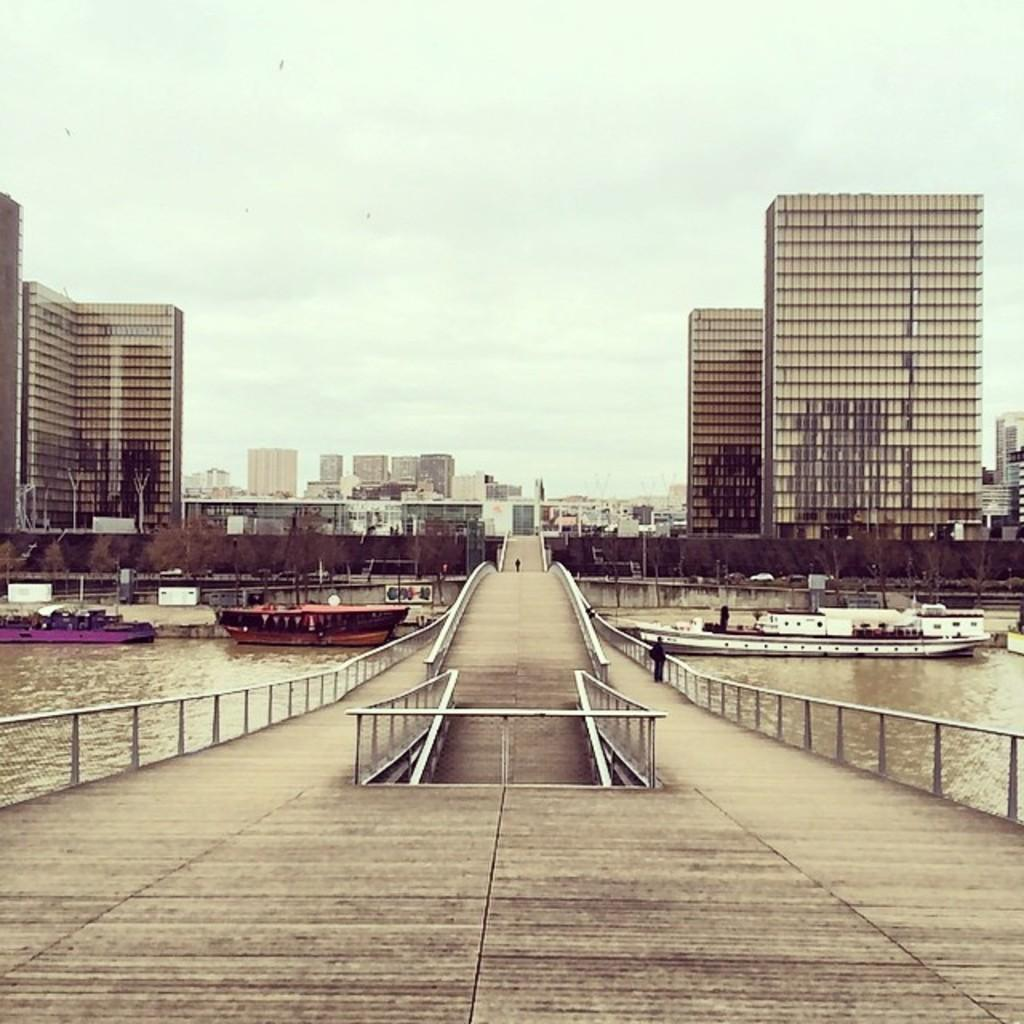What is on the water in the image? There are boats on the water in the image. What structure can be seen crossing over the water? There is a bridge with a fence in the image. What can be seen in the distance behind the bridge? There are buildings visible in the background of the image. What is visible above the bridge and buildings? The sky is visible in the image. How would you describe the weather based on the sky in the image? The sky appears to be cloudy in the image. How many eyes can be seen on the boats in the image? There are no eyes visible on the boats in the image. What achievements can be seen on the bridge? There are no achievements depicted on the bridge or any other part of the image. 